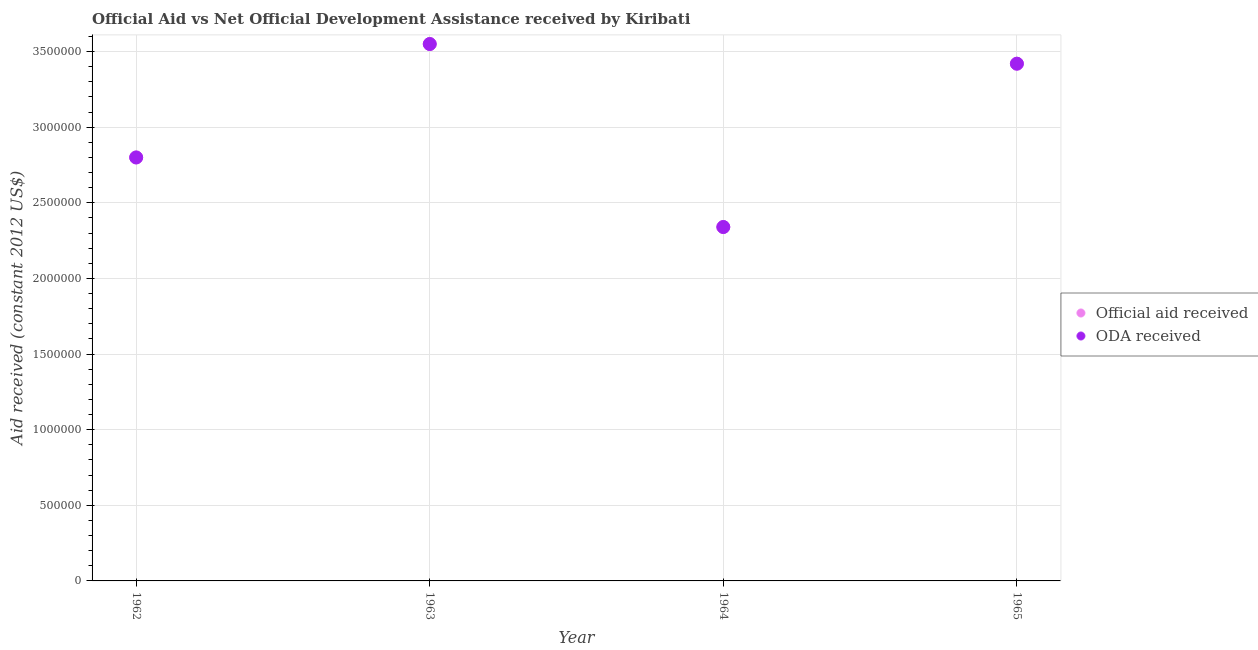Is the number of dotlines equal to the number of legend labels?
Keep it short and to the point. Yes. What is the official aid received in 1964?
Your answer should be compact. 2.34e+06. Across all years, what is the maximum oda received?
Offer a very short reply. 3.55e+06. Across all years, what is the minimum official aid received?
Your answer should be compact. 2.34e+06. In which year was the oda received minimum?
Your answer should be very brief. 1964. What is the total official aid received in the graph?
Your response must be concise. 1.21e+07. What is the difference between the oda received in 1963 and that in 1964?
Your answer should be compact. 1.21e+06. What is the difference between the official aid received in 1965 and the oda received in 1964?
Give a very brief answer. 1.08e+06. What is the average official aid received per year?
Offer a very short reply. 3.03e+06. In the year 1965, what is the difference between the oda received and official aid received?
Offer a very short reply. 0. In how many years, is the oda received greater than 1600000 US$?
Keep it short and to the point. 4. What is the ratio of the official aid received in 1963 to that in 1964?
Your answer should be very brief. 1.52. Is the oda received in 1962 less than that in 1965?
Your answer should be compact. Yes. What is the difference between the highest and the second highest official aid received?
Your answer should be very brief. 1.30e+05. What is the difference between the highest and the lowest official aid received?
Give a very brief answer. 1.21e+06. Does the official aid received monotonically increase over the years?
Make the answer very short. No. Is the official aid received strictly greater than the oda received over the years?
Your answer should be very brief. No. Is the oda received strictly less than the official aid received over the years?
Give a very brief answer. No. Does the graph contain grids?
Ensure brevity in your answer.  Yes. Where does the legend appear in the graph?
Offer a terse response. Center right. What is the title of the graph?
Offer a very short reply. Official Aid vs Net Official Development Assistance received by Kiribati . What is the label or title of the X-axis?
Your answer should be very brief. Year. What is the label or title of the Y-axis?
Ensure brevity in your answer.  Aid received (constant 2012 US$). What is the Aid received (constant 2012 US$) of Official aid received in 1962?
Make the answer very short. 2.80e+06. What is the Aid received (constant 2012 US$) in ODA received in 1962?
Give a very brief answer. 2.80e+06. What is the Aid received (constant 2012 US$) of Official aid received in 1963?
Offer a terse response. 3.55e+06. What is the Aid received (constant 2012 US$) of ODA received in 1963?
Make the answer very short. 3.55e+06. What is the Aid received (constant 2012 US$) of Official aid received in 1964?
Your answer should be compact. 2.34e+06. What is the Aid received (constant 2012 US$) in ODA received in 1964?
Provide a succinct answer. 2.34e+06. What is the Aid received (constant 2012 US$) in Official aid received in 1965?
Keep it short and to the point. 3.42e+06. What is the Aid received (constant 2012 US$) of ODA received in 1965?
Your answer should be very brief. 3.42e+06. Across all years, what is the maximum Aid received (constant 2012 US$) of Official aid received?
Your answer should be very brief. 3.55e+06. Across all years, what is the maximum Aid received (constant 2012 US$) in ODA received?
Your answer should be compact. 3.55e+06. Across all years, what is the minimum Aid received (constant 2012 US$) of Official aid received?
Make the answer very short. 2.34e+06. Across all years, what is the minimum Aid received (constant 2012 US$) in ODA received?
Provide a succinct answer. 2.34e+06. What is the total Aid received (constant 2012 US$) in Official aid received in the graph?
Provide a succinct answer. 1.21e+07. What is the total Aid received (constant 2012 US$) in ODA received in the graph?
Your answer should be compact. 1.21e+07. What is the difference between the Aid received (constant 2012 US$) of Official aid received in 1962 and that in 1963?
Give a very brief answer. -7.50e+05. What is the difference between the Aid received (constant 2012 US$) of ODA received in 1962 and that in 1963?
Your response must be concise. -7.50e+05. What is the difference between the Aid received (constant 2012 US$) in ODA received in 1962 and that in 1964?
Your answer should be very brief. 4.60e+05. What is the difference between the Aid received (constant 2012 US$) in Official aid received in 1962 and that in 1965?
Keep it short and to the point. -6.20e+05. What is the difference between the Aid received (constant 2012 US$) of ODA received in 1962 and that in 1965?
Ensure brevity in your answer.  -6.20e+05. What is the difference between the Aid received (constant 2012 US$) of Official aid received in 1963 and that in 1964?
Your response must be concise. 1.21e+06. What is the difference between the Aid received (constant 2012 US$) of ODA received in 1963 and that in 1964?
Ensure brevity in your answer.  1.21e+06. What is the difference between the Aid received (constant 2012 US$) of Official aid received in 1963 and that in 1965?
Your answer should be very brief. 1.30e+05. What is the difference between the Aid received (constant 2012 US$) in Official aid received in 1964 and that in 1965?
Your answer should be compact. -1.08e+06. What is the difference between the Aid received (constant 2012 US$) of ODA received in 1964 and that in 1965?
Ensure brevity in your answer.  -1.08e+06. What is the difference between the Aid received (constant 2012 US$) in Official aid received in 1962 and the Aid received (constant 2012 US$) in ODA received in 1963?
Give a very brief answer. -7.50e+05. What is the difference between the Aid received (constant 2012 US$) of Official aid received in 1962 and the Aid received (constant 2012 US$) of ODA received in 1965?
Your response must be concise. -6.20e+05. What is the difference between the Aid received (constant 2012 US$) in Official aid received in 1963 and the Aid received (constant 2012 US$) in ODA received in 1964?
Give a very brief answer. 1.21e+06. What is the difference between the Aid received (constant 2012 US$) of Official aid received in 1963 and the Aid received (constant 2012 US$) of ODA received in 1965?
Make the answer very short. 1.30e+05. What is the difference between the Aid received (constant 2012 US$) of Official aid received in 1964 and the Aid received (constant 2012 US$) of ODA received in 1965?
Your answer should be very brief. -1.08e+06. What is the average Aid received (constant 2012 US$) in Official aid received per year?
Offer a very short reply. 3.03e+06. What is the average Aid received (constant 2012 US$) of ODA received per year?
Ensure brevity in your answer.  3.03e+06. In the year 1962, what is the difference between the Aid received (constant 2012 US$) of Official aid received and Aid received (constant 2012 US$) of ODA received?
Your answer should be very brief. 0. In the year 1963, what is the difference between the Aid received (constant 2012 US$) of Official aid received and Aid received (constant 2012 US$) of ODA received?
Give a very brief answer. 0. What is the ratio of the Aid received (constant 2012 US$) in Official aid received in 1962 to that in 1963?
Your response must be concise. 0.79. What is the ratio of the Aid received (constant 2012 US$) in ODA received in 1962 to that in 1963?
Ensure brevity in your answer.  0.79. What is the ratio of the Aid received (constant 2012 US$) of Official aid received in 1962 to that in 1964?
Your answer should be very brief. 1.2. What is the ratio of the Aid received (constant 2012 US$) of ODA received in 1962 to that in 1964?
Your response must be concise. 1.2. What is the ratio of the Aid received (constant 2012 US$) in Official aid received in 1962 to that in 1965?
Your answer should be compact. 0.82. What is the ratio of the Aid received (constant 2012 US$) in ODA received in 1962 to that in 1965?
Provide a short and direct response. 0.82. What is the ratio of the Aid received (constant 2012 US$) in Official aid received in 1963 to that in 1964?
Your answer should be compact. 1.52. What is the ratio of the Aid received (constant 2012 US$) of ODA received in 1963 to that in 1964?
Give a very brief answer. 1.52. What is the ratio of the Aid received (constant 2012 US$) of Official aid received in 1963 to that in 1965?
Offer a terse response. 1.04. What is the ratio of the Aid received (constant 2012 US$) in ODA received in 1963 to that in 1965?
Keep it short and to the point. 1.04. What is the ratio of the Aid received (constant 2012 US$) of Official aid received in 1964 to that in 1965?
Keep it short and to the point. 0.68. What is the ratio of the Aid received (constant 2012 US$) in ODA received in 1964 to that in 1965?
Give a very brief answer. 0.68. What is the difference between the highest and the second highest Aid received (constant 2012 US$) of ODA received?
Provide a succinct answer. 1.30e+05. What is the difference between the highest and the lowest Aid received (constant 2012 US$) in Official aid received?
Offer a terse response. 1.21e+06. What is the difference between the highest and the lowest Aid received (constant 2012 US$) of ODA received?
Keep it short and to the point. 1.21e+06. 